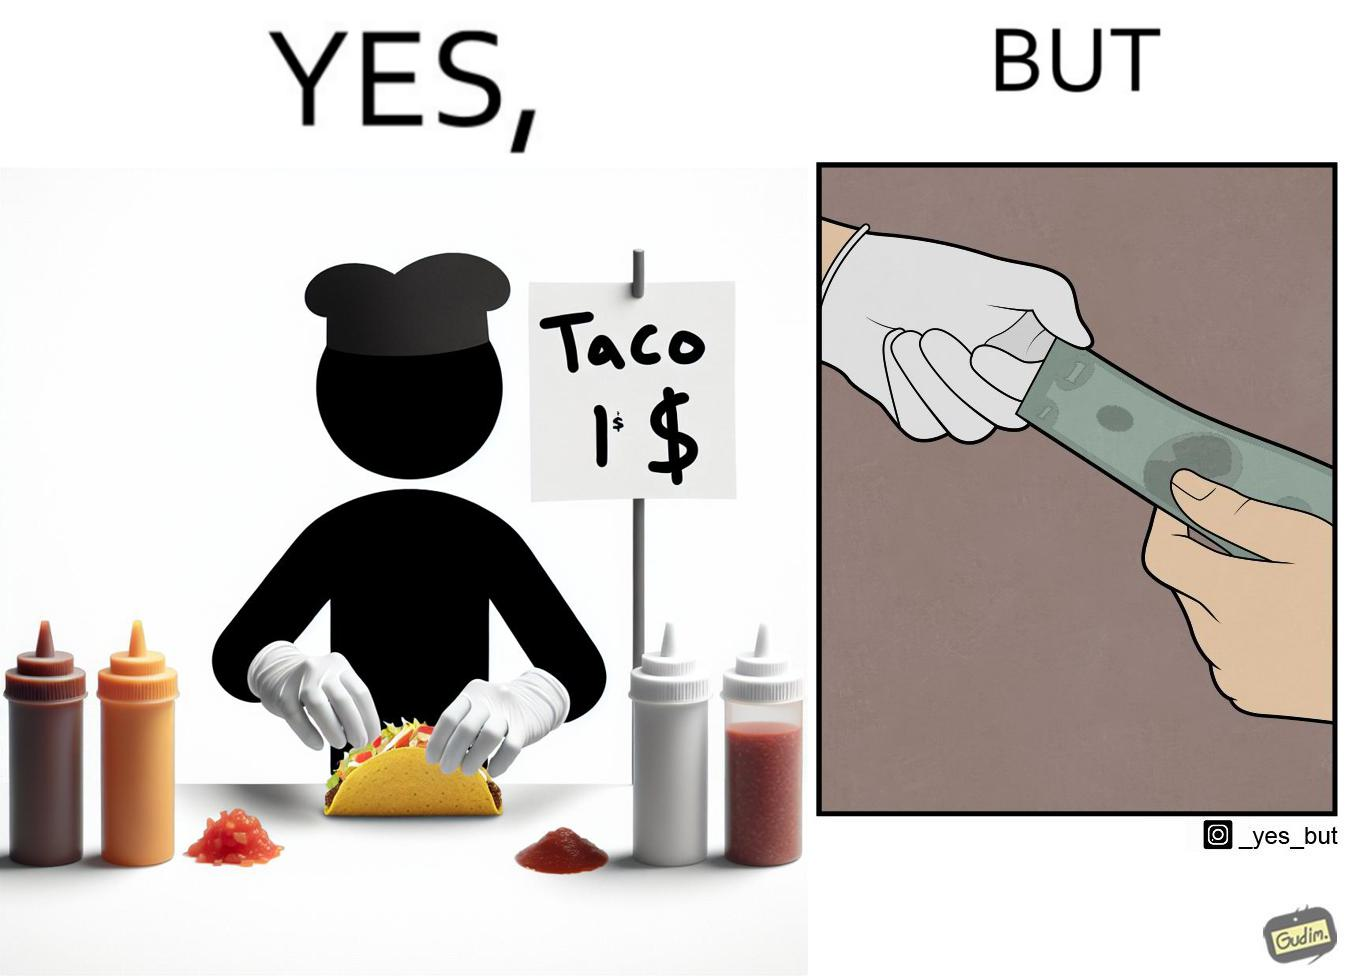Explain why this image is satirical. The image is satirical because the intention of wearing a glove while preparing food is to not let any germs and dirt from our hands get into the food, people do other tasks like collecting money from the customer wearing the same gloves and thus making the gloves themselves dirty. 